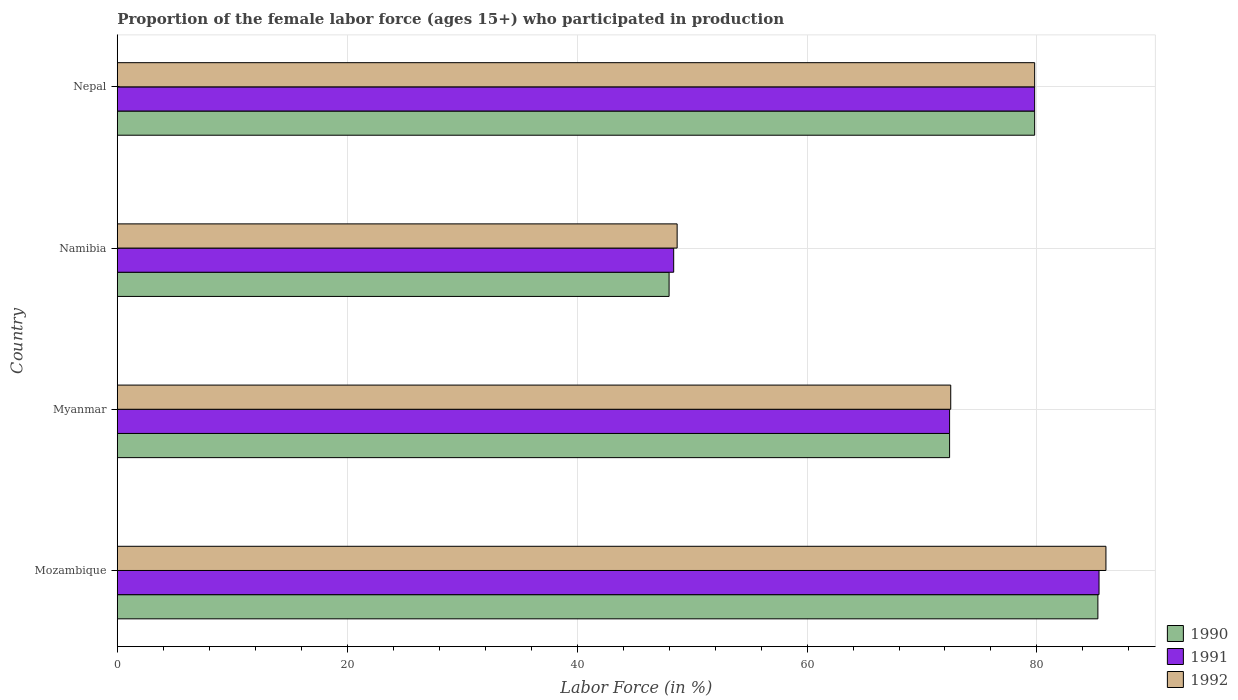How many different coloured bars are there?
Provide a short and direct response. 3. How many groups of bars are there?
Offer a very short reply. 4. How many bars are there on the 1st tick from the bottom?
Your answer should be very brief. 3. What is the label of the 1st group of bars from the top?
Ensure brevity in your answer.  Nepal. Across all countries, what is the minimum proportion of the female labor force who participated in production in 1991?
Offer a very short reply. 48.4. In which country was the proportion of the female labor force who participated in production in 1991 maximum?
Your response must be concise. Mozambique. In which country was the proportion of the female labor force who participated in production in 1992 minimum?
Ensure brevity in your answer.  Namibia. What is the total proportion of the female labor force who participated in production in 1991 in the graph?
Offer a very short reply. 286. What is the difference between the proportion of the female labor force who participated in production in 1990 in Nepal and the proportion of the female labor force who participated in production in 1992 in Mozambique?
Offer a terse response. -6.2. What is the average proportion of the female labor force who participated in production in 1991 per country?
Your response must be concise. 71.5. What is the difference between the proportion of the female labor force who participated in production in 1991 and proportion of the female labor force who participated in production in 1992 in Nepal?
Your answer should be very brief. 0. In how many countries, is the proportion of the female labor force who participated in production in 1991 greater than 44 %?
Provide a short and direct response. 4. What is the ratio of the proportion of the female labor force who participated in production in 1992 in Myanmar to that in Nepal?
Provide a succinct answer. 0.91. What is the difference between the highest and the second highest proportion of the female labor force who participated in production in 1991?
Provide a short and direct response. 5.6. What is the difference between the highest and the lowest proportion of the female labor force who participated in production in 1992?
Your answer should be very brief. 37.3. Is the sum of the proportion of the female labor force who participated in production in 1992 in Mozambique and Myanmar greater than the maximum proportion of the female labor force who participated in production in 1991 across all countries?
Your answer should be very brief. Yes. What does the 2nd bar from the top in Nepal represents?
Offer a terse response. 1991. What does the 2nd bar from the bottom in Namibia represents?
Offer a terse response. 1991. How many bars are there?
Provide a short and direct response. 12. Are all the bars in the graph horizontal?
Provide a succinct answer. Yes. How many countries are there in the graph?
Your answer should be very brief. 4. What is the difference between two consecutive major ticks on the X-axis?
Give a very brief answer. 20. Are the values on the major ticks of X-axis written in scientific E-notation?
Offer a terse response. No. Does the graph contain any zero values?
Your answer should be compact. No. Where does the legend appear in the graph?
Provide a succinct answer. Bottom right. What is the title of the graph?
Your answer should be very brief. Proportion of the female labor force (ages 15+) who participated in production. Does "2006" appear as one of the legend labels in the graph?
Provide a succinct answer. No. What is the Labor Force (in %) of 1990 in Mozambique?
Your answer should be very brief. 85.3. What is the Labor Force (in %) in 1991 in Mozambique?
Provide a succinct answer. 85.4. What is the Labor Force (in %) in 1992 in Mozambique?
Your answer should be compact. 86. What is the Labor Force (in %) in 1990 in Myanmar?
Give a very brief answer. 72.4. What is the Labor Force (in %) in 1991 in Myanmar?
Ensure brevity in your answer.  72.4. What is the Labor Force (in %) of 1992 in Myanmar?
Keep it short and to the point. 72.5. What is the Labor Force (in %) of 1990 in Namibia?
Offer a very short reply. 48. What is the Labor Force (in %) of 1991 in Namibia?
Your response must be concise. 48.4. What is the Labor Force (in %) of 1992 in Namibia?
Your answer should be very brief. 48.7. What is the Labor Force (in %) in 1990 in Nepal?
Provide a succinct answer. 79.8. What is the Labor Force (in %) in 1991 in Nepal?
Your response must be concise. 79.8. What is the Labor Force (in %) in 1992 in Nepal?
Your response must be concise. 79.8. Across all countries, what is the maximum Labor Force (in %) in 1990?
Make the answer very short. 85.3. Across all countries, what is the maximum Labor Force (in %) in 1991?
Provide a succinct answer. 85.4. Across all countries, what is the minimum Labor Force (in %) of 1990?
Your answer should be very brief. 48. Across all countries, what is the minimum Labor Force (in %) in 1991?
Ensure brevity in your answer.  48.4. Across all countries, what is the minimum Labor Force (in %) in 1992?
Offer a terse response. 48.7. What is the total Labor Force (in %) of 1990 in the graph?
Provide a succinct answer. 285.5. What is the total Labor Force (in %) in 1991 in the graph?
Provide a short and direct response. 286. What is the total Labor Force (in %) in 1992 in the graph?
Give a very brief answer. 287. What is the difference between the Labor Force (in %) of 1991 in Mozambique and that in Myanmar?
Offer a terse response. 13. What is the difference between the Labor Force (in %) in 1992 in Mozambique and that in Myanmar?
Ensure brevity in your answer.  13.5. What is the difference between the Labor Force (in %) in 1990 in Mozambique and that in Namibia?
Keep it short and to the point. 37.3. What is the difference between the Labor Force (in %) of 1991 in Mozambique and that in Namibia?
Your response must be concise. 37. What is the difference between the Labor Force (in %) in 1992 in Mozambique and that in Namibia?
Keep it short and to the point. 37.3. What is the difference between the Labor Force (in %) of 1990 in Mozambique and that in Nepal?
Your answer should be compact. 5.5. What is the difference between the Labor Force (in %) in 1992 in Mozambique and that in Nepal?
Your answer should be very brief. 6.2. What is the difference between the Labor Force (in %) in 1990 in Myanmar and that in Namibia?
Offer a very short reply. 24.4. What is the difference between the Labor Force (in %) of 1992 in Myanmar and that in Namibia?
Provide a short and direct response. 23.8. What is the difference between the Labor Force (in %) of 1990 in Namibia and that in Nepal?
Provide a short and direct response. -31.8. What is the difference between the Labor Force (in %) in 1991 in Namibia and that in Nepal?
Your answer should be very brief. -31.4. What is the difference between the Labor Force (in %) in 1992 in Namibia and that in Nepal?
Provide a short and direct response. -31.1. What is the difference between the Labor Force (in %) of 1990 in Mozambique and the Labor Force (in %) of 1991 in Myanmar?
Provide a succinct answer. 12.9. What is the difference between the Labor Force (in %) of 1990 in Mozambique and the Labor Force (in %) of 1991 in Namibia?
Offer a very short reply. 36.9. What is the difference between the Labor Force (in %) of 1990 in Mozambique and the Labor Force (in %) of 1992 in Namibia?
Offer a terse response. 36.6. What is the difference between the Labor Force (in %) of 1991 in Mozambique and the Labor Force (in %) of 1992 in Namibia?
Your answer should be compact. 36.7. What is the difference between the Labor Force (in %) in 1990 in Mozambique and the Labor Force (in %) in 1991 in Nepal?
Your response must be concise. 5.5. What is the difference between the Labor Force (in %) of 1990 in Mozambique and the Labor Force (in %) of 1992 in Nepal?
Offer a very short reply. 5.5. What is the difference between the Labor Force (in %) of 1990 in Myanmar and the Labor Force (in %) of 1992 in Namibia?
Offer a very short reply. 23.7. What is the difference between the Labor Force (in %) of 1991 in Myanmar and the Labor Force (in %) of 1992 in Namibia?
Your answer should be very brief. 23.7. What is the difference between the Labor Force (in %) in 1990 in Myanmar and the Labor Force (in %) in 1991 in Nepal?
Give a very brief answer. -7.4. What is the difference between the Labor Force (in %) in 1990 in Myanmar and the Labor Force (in %) in 1992 in Nepal?
Your response must be concise. -7.4. What is the difference between the Labor Force (in %) of 1990 in Namibia and the Labor Force (in %) of 1991 in Nepal?
Your answer should be very brief. -31.8. What is the difference between the Labor Force (in %) in 1990 in Namibia and the Labor Force (in %) in 1992 in Nepal?
Your answer should be very brief. -31.8. What is the difference between the Labor Force (in %) of 1991 in Namibia and the Labor Force (in %) of 1992 in Nepal?
Give a very brief answer. -31.4. What is the average Labor Force (in %) of 1990 per country?
Your answer should be very brief. 71.38. What is the average Labor Force (in %) of 1991 per country?
Make the answer very short. 71.5. What is the average Labor Force (in %) of 1992 per country?
Offer a very short reply. 71.75. What is the difference between the Labor Force (in %) in 1990 and Labor Force (in %) in 1991 in Mozambique?
Ensure brevity in your answer.  -0.1. What is the difference between the Labor Force (in %) in 1991 and Labor Force (in %) in 1992 in Mozambique?
Provide a succinct answer. -0.6. What is the difference between the Labor Force (in %) of 1990 and Labor Force (in %) of 1992 in Myanmar?
Provide a short and direct response. -0.1. What is the difference between the Labor Force (in %) of 1991 and Labor Force (in %) of 1992 in Myanmar?
Provide a short and direct response. -0.1. What is the difference between the Labor Force (in %) of 1990 and Labor Force (in %) of 1992 in Namibia?
Offer a very short reply. -0.7. What is the difference between the Labor Force (in %) of 1991 and Labor Force (in %) of 1992 in Namibia?
Your answer should be very brief. -0.3. What is the difference between the Labor Force (in %) in 1990 and Labor Force (in %) in 1991 in Nepal?
Offer a very short reply. 0. What is the difference between the Labor Force (in %) of 1990 and Labor Force (in %) of 1992 in Nepal?
Your answer should be very brief. 0. What is the difference between the Labor Force (in %) in 1991 and Labor Force (in %) in 1992 in Nepal?
Offer a terse response. 0. What is the ratio of the Labor Force (in %) in 1990 in Mozambique to that in Myanmar?
Give a very brief answer. 1.18. What is the ratio of the Labor Force (in %) in 1991 in Mozambique to that in Myanmar?
Your response must be concise. 1.18. What is the ratio of the Labor Force (in %) in 1992 in Mozambique to that in Myanmar?
Provide a short and direct response. 1.19. What is the ratio of the Labor Force (in %) of 1990 in Mozambique to that in Namibia?
Give a very brief answer. 1.78. What is the ratio of the Labor Force (in %) in 1991 in Mozambique to that in Namibia?
Ensure brevity in your answer.  1.76. What is the ratio of the Labor Force (in %) in 1992 in Mozambique to that in Namibia?
Offer a terse response. 1.77. What is the ratio of the Labor Force (in %) of 1990 in Mozambique to that in Nepal?
Make the answer very short. 1.07. What is the ratio of the Labor Force (in %) in 1991 in Mozambique to that in Nepal?
Offer a terse response. 1.07. What is the ratio of the Labor Force (in %) of 1992 in Mozambique to that in Nepal?
Ensure brevity in your answer.  1.08. What is the ratio of the Labor Force (in %) of 1990 in Myanmar to that in Namibia?
Make the answer very short. 1.51. What is the ratio of the Labor Force (in %) of 1991 in Myanmar to that in Namibia?
Your answer should be very brief. 1.5. What is the ratio of the Labor Force (in %) of 1992 in Myanmar to that in Namibia?
Your answer should be very brief. 1.49. What is the ratio of the Labor Force (in %) in 1990 in Myanmar to that in Nepal?
Give a very brief answer. 0.91. What is the ratio of the Labor Force (in %) in 1991 in Myanmar to that in Nepal?
Your answer should be compact. 0.91. What is the ratio of the Labor Force (in %) in 1992 in Myanmar to that in Nepal?
Offer a very short reply. 0.91. What is the ratio of the Labor Force (in %) in 1990 in Namibia to that in Nepal?
Offer a very short reply. 0.6. What is the ratio of the Labor Force (in %) in 1991 in Namibia to that in Nepal?
Your answer should be compact. 0.61. What is the ratio of the Labor Force (in %) in 1992 in Namibia to that in Nepal?
Keep it short and to the point. 0.61. What is the difference between the highest and the second highest Labor Force (in %) of 1990?
Offer a very short reply. 5.5. What is the difference between the highest and the second highest Labor Force (in %) in 1991?
Make the answer very short. 5.6. What is the difference between the highest and the lowest Labor Force (in %) in 1990?
Your answer should be very brief. 37.3. What is the difference between the highest and the lowest Labor Force (in %) of 1992?
Your answer should be compact. 37.3. 